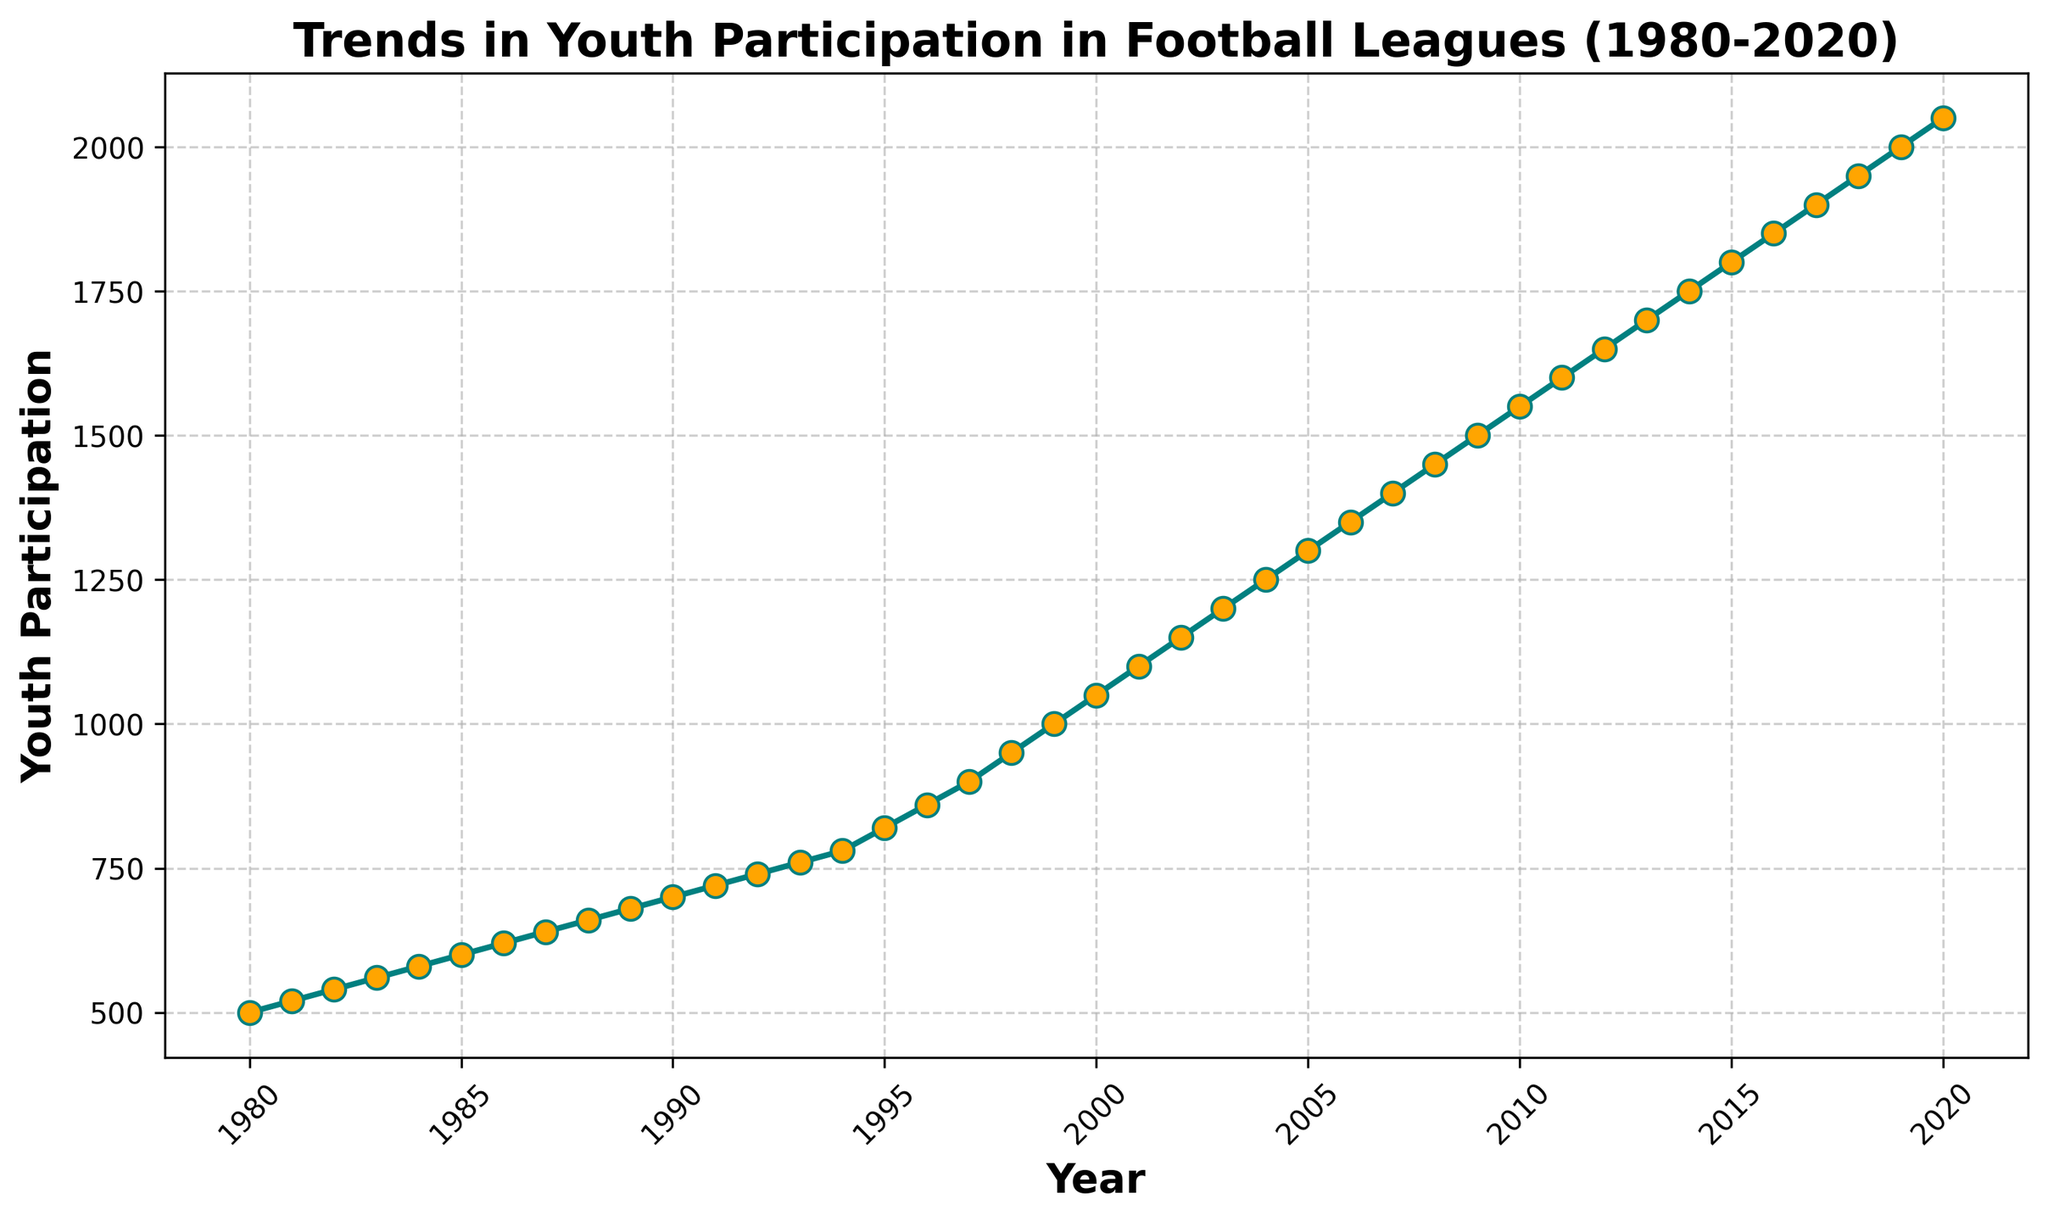How many years did it take for youth participation to double from 1980? In 1980, the youth participation was 500. To find when it doubles, we need to find the year where it reaches 1000. From the chart, in 1999, the participation is 1000. It took from 1980 to 1999, which is 19 years.
Answer: 19 years In what year did the youth participation first reach 1500? By examining the chart, we find that the participation first hits 1500 in the year 2009.
Answer: 2009 What is the average annual increase in youth participation from 1980 to 2020? Between 1980 and 2020, youth participation increased from 500 to 2050. The difference is 2050 - 500 = 1550. The number of years is 2020 - 1980 = 40. The average annual increase is 1550 / 40 = 38.75.
Answer: 38.75 Between which years did the youth participation see the largest increase? By comparing the increments year over year on the chart, the largest increase happens between 1994 and 1995 where the participation jumps from 780 to 820, a difference of 40 participants.
Answer: 1994 to 1995 What was the youth participation in the year 2000? From the chart, the youth participation in the year 2000 is 1050.
Answer: 1050 Compare the youth participation in 1990 and 2000? In 1990, the participation was 700, and in 2000 it was 1050. 1050 is greater than 700 by 350 participants.
Answer: 1050 is greater than 700 by 350 What is the percentage increase in youth participation from 1980 to 2020? Starting with 500 in 1980 and increasing to 2050 in 2020, the change is 1550 participants. The percentage increase is (1550 / 500) * 100 = 310%.
Answer: 310% Is there a year where the youth participation remained the same as the previous year? By checking the chart carefully, there is no year where the participation remained the same as every year shows an increase.
Answer: No When did the youth participation reach 2000, and what was the increase from the previous year? The participation reached 2000 in 2019. In 2018, it was 1950, so the increase was 2000 - 1950 = 50.
Answer: 2019, increase by 50 What is the median youth participation for the entire period from 1980 to 2020? The median is the middle value in a sorted list. For 41 entries, the median will be the 21st value. From the chart, the 21st value (year 2000) is 1050.
Answer: 1050 